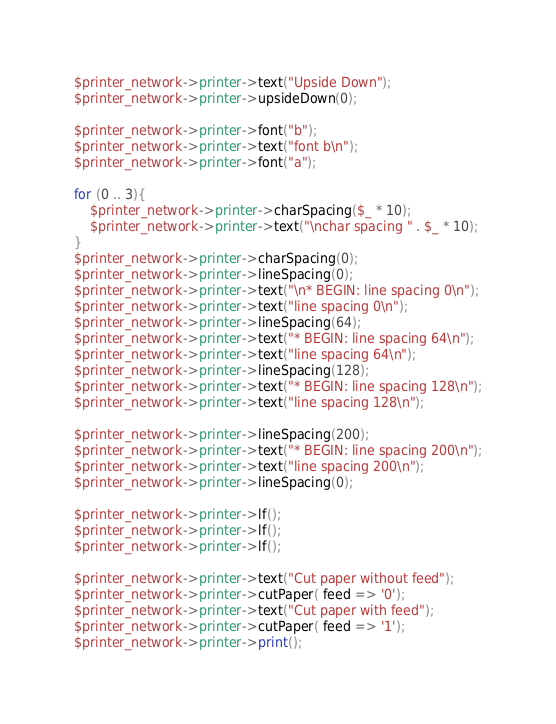<code> <loc_0><loc_0><loc_500><loc_500><_Perl_>$printer_network->printer->text("Upside Down");
$printer_network->printer->upsideDown(0);

$printer_network->printer->font("b");
$printer_network->printer->text("font b\n");
$printer_network->printer->font("a");

for (0 .. 3){
    $printer_network->printer->charSpacing($_ * 10);
    $printer_network->printer->text("\nchar spacing " . $_ * 10);
}
$printer_network->printer->charSpacing(0);
$printer_network->printer->lineSpacing(0);
$printer_network->printer->text("\n* BEGIN: line spacing 0\n");
$printer_network->printer->text("line spacing 0\n");
$printer_network->printer->lineSpacing(64);
$printer_network->printer->text("* BEGIN: line spacing 64\n");
$printer_network->printer->text("line spacing 64\n");
$printer_network->printer->lineSpacing(128);
$printer_network->printer->text("* BEGIN: line spacing 128\n");
$printer_network->printer->text("line spacing 128\n");

$printer_network->printer->lineSpacing(200);
$printer_network->printer->text("* BEGIN: line spacing 200\n");
$printer_network->printer->text("line spacing 200\n");
$printer_network->printer->lineSpacing(0);

$printer_network->printer->lf();
$printer_network->printer->lf();
$printer_network->printer->lf();

$printer_network->printer->text("Cut paper without feed");
$printer_network->printer->cutPaper( feed => '0');
$printer_network->printer->text("Cut paper with feed");
$printer_network->printer->cutPaper( feed => '1');
$printer_network->printer->print();
</code> 